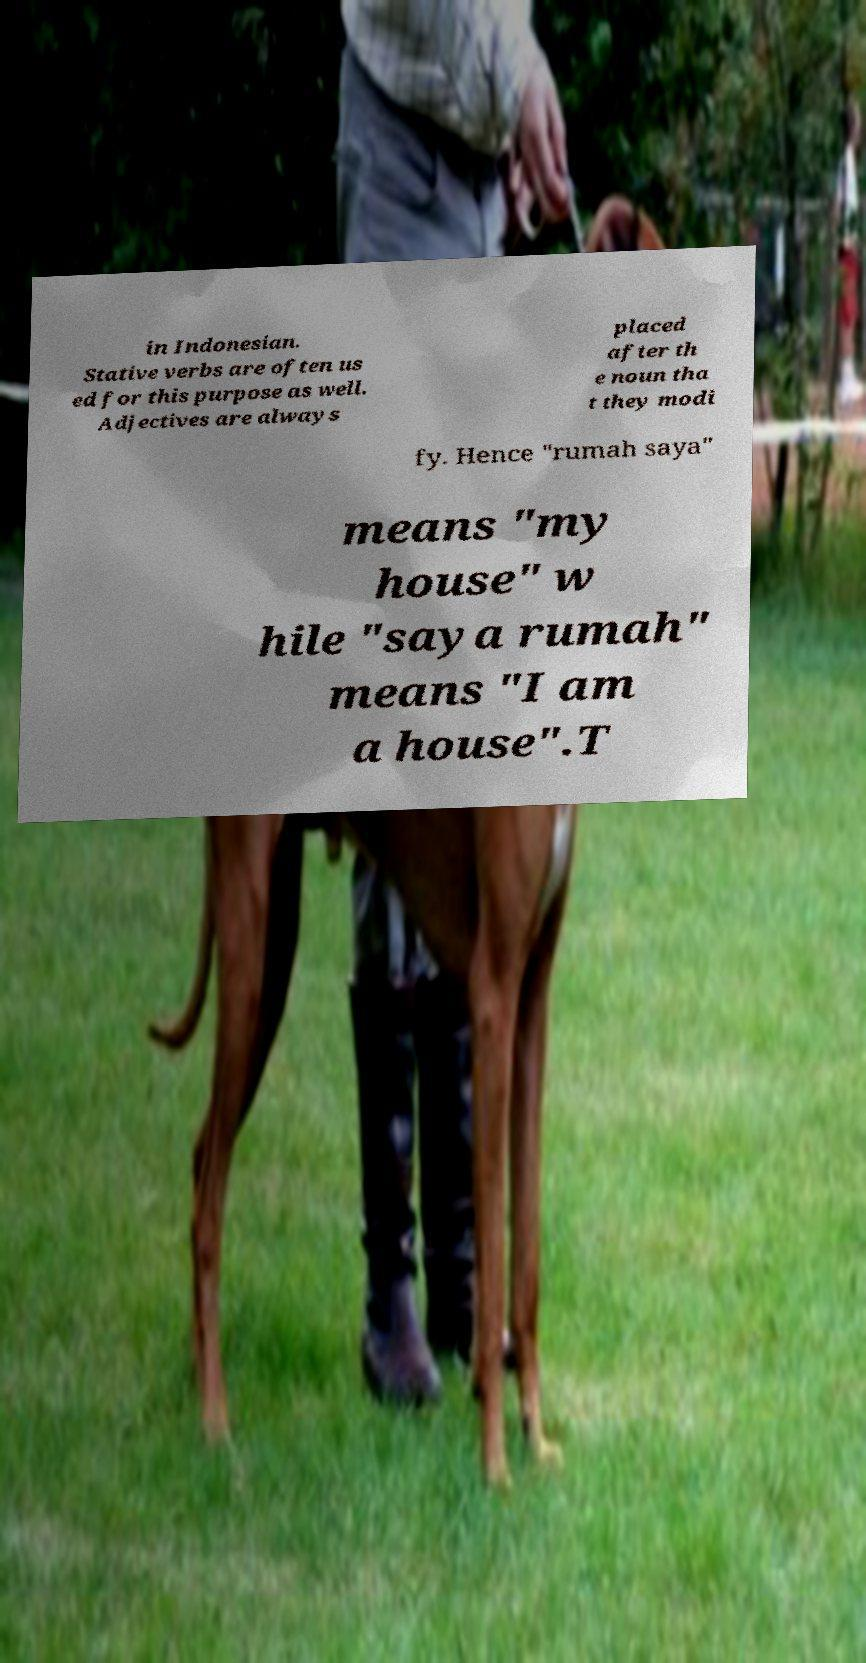What messages or text are displayed in this image? I need them in a readable, typed format. in Indonesian. Stative verbs are often us ed for this purpose as well. Adjectives are always placed after th e noun tha t they modi fy. Hence "rumah saya" means "my house" w hile "saya rumah" means "I am a house".T 